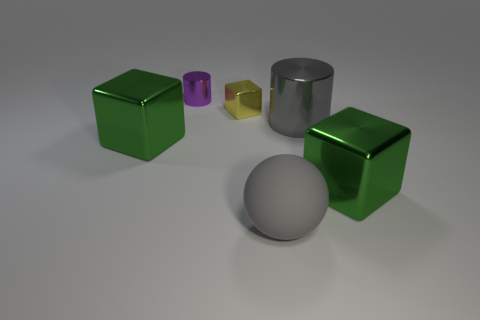Subtract all large cubes. How many cubes are left? 1 Add 3 tiny cyan metallic cylinders. How many objects exist? 9 Subtract 1 spheres. How many spheres are left? 0 Subtract all purple cylinders. How many cylinders are left? 1 Subtract all cylinders. How many objects are left? 4 Subtract all purple cylinders. How many yellow blocks are left? 1 Add 4 cyan matte things. How many cyan matte things exist? 4 Subtract 0 yellow cylinders. How many objects are left? 6 Subtract all yellow cubes. Subtract all yellow spheres. How many cubes are left? 2 Subtract all large green shiny cubes. Subtract all large gray spheres. How many objects are left? 3 